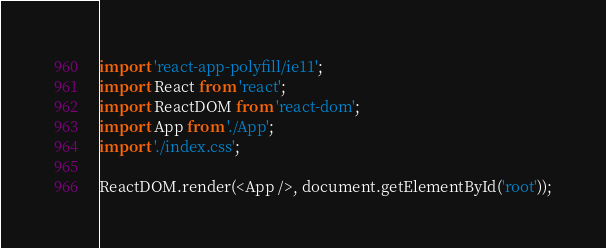<code> <loc_0><loc_0><loc_500><loc_500><_JavaScript_>import 'react-app-polyfill/ie11';
import React from 'react';
import ReactDOM from 'react-dom';
import App from './App';
import './index.css';

ReactDOM.render(<App />, document.getElementById('root'));
</code> 